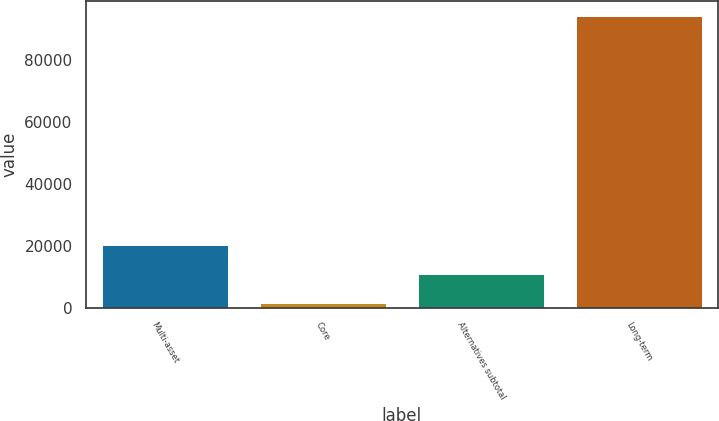Convert chart to OTSL. <chart><loc_0><loc_0><loc_500><loc_500><bar_chart><fcel>Multi-asset<fcel>Core<fcel>Alternatives subtotal<fcel>Long-term<nl><fcel>20220<fcel>1641<fcel>10930.5<fcel>94536<nl></chart> 